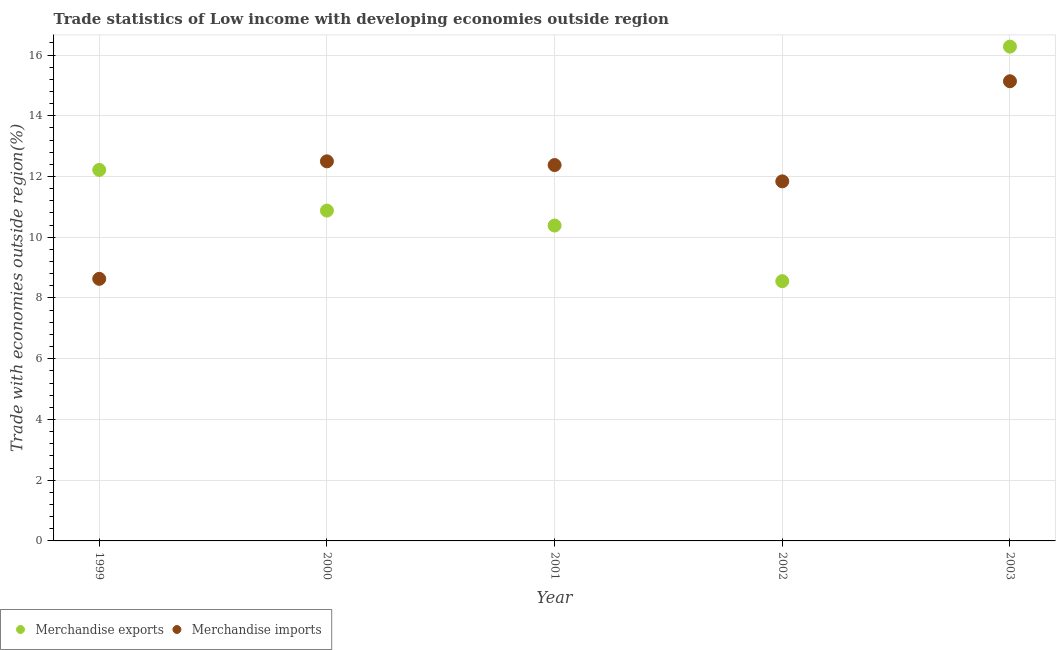How many different coloured dotlines are there?
Give a very brief answer. 2. What is the merchandise imports in 2002?
Give a very brief answer. 11.84. Across all years, what is the maximum merchandise imports?
Your response must be concise. 15.14. Across all years, what is the minimum merchandise imports?
Offer a terse response. 8.63. What is the total merchandise imports in the graph?
Offer a terse response. 60.48. What is the difference between the merchandise exports in 2001 and that in 2002?
Your response must be concise. 1.83. What is the difference between the merchandise exports in 1999 and the merchandise imports in 2000?
Provide a short and direct response. -0.28. What is the average merchandise imports per year?
Your response must be concise. 12.1. In the year 2003, what is the difference between the merchandise exports and merchandise imports?
Provide a succinct answer. 1.14. What is the ratio of the merchandise imports in 1999 to that in 2000?
Your response must be concise. 0.69. Is the difference between the merchandise imports in 2000 and 2001 greater than the difference between the merchandise exports in 2000 and 2001?
Keep it short and to the point. No. What is the difference between the highest and the second highest merchandise imports?
Offer a terse response. 2.64. What is the difference between the highest and the lowest merchandise exports?
Make the answer very short. 7.72. In how many years, is the merchandise exports greater than the average merchandise exports taken over all years?
Offer a terse response. 2. Is the sum of the merchandise imports in 2002 and 2003 greater than the maximum merchandise exports across all years?
Keep it short and to the point. Yes. Does the merchandise imports monotonically increase over the years?
Give a very brief answer. No. How many dotlines are there?
Ensure brevity in your answer.  2. How many years are there in the graph?
Provide a short and direct response. 5. Does the graph contain any zero values?
Your response must be concise. No. Does the graph contain grids?
Provide a succinct answer. Yes. Where does the legend appear in the graph?
Your response must be concise. Bottom left. How are the legend labels stacked?
Give a very brief answer. Horizontal. What is the title of the graph?
Offer a very short reply. Trade statistics of Low income with developing economies outside region. What is the label or title of the Y-axis?
Make the answer very short. Trade with economies outside region(%). What is the Trade with economies outside region(%) of Merchandise exports in 1999?
Offer a very short reply. 12.22. What is the Trade with economies outside region(%) in Merchandise imports in 1999?
Your response must be concise. 8.63. What is the Trade with economies outside region(%) in Merchandise exports in 2000?
Your response must be concise. 10.88. What is the Trade with economies outside region(%) of Merchandise imports in 2000?
Provide a succinct answer. 12.5. What is the Trade with economies outside region(%) of Merchandise exports in 2001?
Keep it short and to the point. 10.39. What is the Trade with economies outside region(%) in Merchandise imports in 2001?
Keep it short and to the point. 12.38. What is the Trade with economies outside region(%) in Merchandise exports in 2002?
Your answer should be compact. 8.55. What is the Trade with economies outside region(%) in Merchandise imports in 2002?
Make the answer very short. 11.84. What is the Trade with economies outside region(%) in Merchandise exports in 2003?
Provide a short and direct response. 16.28. What is the Trade with economies outside region(%) of Merchandise imports in 2003?
Make the answer very short. 15.14. Across all years, what is the maximum Trade with economies outside region(%) in Merchandise exports?
Your answer should be very brief. 16.28. Across all years, what is the maximum Trade with economies outside region(%) of Merchandise imports?
Your answer should be very brief. 15.14. Across all years, what is the minimum Trade with economies outside region(%) in Merchandise exports?
Provide a succinct answer. 8.55. Across all years, what is the minimum Trade with economies outside region(%) of Merchandise imports?
Provide a short and direct response. 8.63. What is the total Trade with economies outside region(%) in Merchandise exports in the graph?
Ensure brevity in your answer.  58.31. What is the total Trade with economies outside region(%) of Merchandise imports in the graph?
Provide a succinct answer. 60.48. What is the difference between the Trade with economies outside region(%) of Merchandise exports in 1999 and that in 2000?
Give a very brief answer. 1.34. What is the difference between the Trade with economies outside region(%) in Merchandise imports in 1999 and that in 2000?
Give a very brief answer. -3.87. What is the difference between the Trade with economies outside region(%) in Merchandise exports in 1999 and that in 2001?
Keep it short and to the point. 1.83. What is the difference between the Trade with economies outside region(%) of Merchandise imports in 1999 and that in 2001?
Offer a very short reply. -3.75. What is the difference between the Trade with economies outside region(%) in Merchandise exports in 1999 and that in 2002?
Offer a terse response. 3.66. What is the difference between the Trade with economies outside region(%) of Merchandise imports in 1999 and that in 2002?
Provide a succinct answer. -3.21. What is the difference between the Trade with economies outside region(%) in Merchandise exports in 1999 and that in 2003?
Give a very brief answer. -4.06. What is the difference between the Trade with economies outside region(%) in Merchandise imports in 1999 and that in 2003?
Provide a short and direct response. -6.51. What is the difference between the Trade with economies outside region(%) of Merchandise exports in 2000 and that in 2001?
Your answer should be compact. 0.49. What is the difference between the Trade with economies outside region(%) in Merchandise imports in 2000 and that in 2001?
Your response must be concise. 0.12. What is the difference between the Trade with economies outside region(%) in Merchandise exports in 2000 and that in 2002?
Offer a terse response. 2.32. What is the difference between the Trade with economies outside region(%) in Merchandise imports in 2000 and that in 2002?
Make the answer very short. 0.66. What is the difference between the Trade with economies outside region(%) in Merchandise exports in 2000 and that in 2003?
Offer a very short reply. -5.4. What is the difference between the Trade with economies outside region(%) in Merchandise imports in 2000 and that in 2003?
Provide a succinct answer. -2.64. What is the difference between the Trade with economies outside region(%) in Merchandise exports in 2001 and that in 2002?
Offer a terse response. 1.83. What is the difference between the Trade with economies outside region(%) of Merchandise imports in 2001 and that in 2002?
Give a very brief answer. 0.54. What is the difference between the Trade with economies outside region(%) in Merchandise exports in 2001 and that in 2003?
Make the answer very short. -5.89. What is the difference between the Trade with economies outside region(%) of Merchandise imports in 2001 and that in 2003?
Your answer should be compact. -2.76. What is the difference between the Trade with economies outside region(%) in Merchandise exports in 2002 and that in 2003?
Your answer should be compact. -7.72. What is the difference between the Trade with economies outside region(%) of Merchandise imports in 2002 and that in 2003?
Your answer should be compact. -3.3. What is the difference between the Trade with economies outside region(%) of Merchandise exports in 1999 and the Trade with economies outside region(%) of Merchandise imports in 2000?
Offer a terse response. -0.28. What is the difference between the Trade with economies outside region(%) of Merchandise exports in 1999 and the Trade with economies outside region(%) of Merchandise imports in 2001?
Provide a succinct answer. -0.16. What is the difference between the Trade with economies outside region(%) in Merchandise exports in 1999 and the Trade with economies outside region(%) in Merchandise imports in 2002?
Provide a short and direct response. 0.38. What is the difference between the Trade with economies outside region(%) of Merchandise exports in 1999 and the Trade with economies outside region(%) of Merchandise imports in 2003?
Your answer should be very brief. -2.92. What is the difference between the Trade with economies outside region(%) in Merchandise exports in 2000 and the Trade with economies outside region(%) in Merchandise imports in 2001?
Give a very brief answer. -1.5. What is the difference between the Trade with economies outside region(%) in Merchandise exports in 2000 and the Trade with economies outside region(%) in Merchandise imports in 2002?
Provide a short and direct response. -0.96. What is the difference between the Trade with economies outside region(%) in Merchandise exports in 2000 and the Trade with economies outside region(%) in Merchandise imports in 2003?
Give a very brief answer. -4.26. What is the difference between the Trade with economies outside region(%) in Merchandise exports in 2001 and the Trade with economies outside region(%) in Merchandise imports in 2002?
Offer a very short reply. -1.45. What is the difference between the Trade with economies outside region(%) of Merchandise exports in 2001 and the Trade with economies outside region(%) of Merchandise imports in 2003?
Give a very brief answer. -4.75. What is the difference between the Trade with economies outside region(%) in Merchandise exports in 2002 and the Trade with economies outside region(%) in Merchandise imports in 2003?
Give a very brief answer. -6.58. What is the average Trade with economies outside region(%) in Merchandise exports per year?
Make the answer very short. 11.66. What is the average Trade with economies outside region(%) in Merchandise imports per year?
Your answer should be very brief. 12.1. In the year 1999, what is the difference between the Trade with economies outside region(%) in Merchandise exports and Trade with economies outside region(%) in Merchandise imports?
Make the answer very short. 3.59. In the year 2000, what is the difference between the Trade with economies outside region(%) in Merchandise exports and Trade with economies outside region(%) in Merchandise imports?
Keep it short and to the point. -1.62. In the year 2001, what is the difference between the Trade with economies outside region(%) of Merchandise exports and Trade with economies outside region(%) of Merchandise imports?
Give a very brief answer. -1.99. In the year 2002, what is the difference between the Trade with economies outside region(%) in Merchandise exports and Trade with economies outside region(%) in Merchandise imports?
Offer a very short reply. -3.29. In the year 2003, what is the difference between the Trade with economies outside region(%) in Merchandise exports and Trade with economies outside region(%) in Merchandise imports?
Keep it short and to the point. 1.14. What is the ratio of the Trade with economies outside region(%) of Merchandise exports in 1999 to that in 2000?
Offer a very short reply. 1.12. What is the ratio of the Trade with economies outside region(%) of Merchandise imports in 1999 to that in 2000?
Ensure brevity in your answer.  0.69. What is the ratio of the Trade with economies outside region(%) in Merchandise exports in 1999 to that in 2001?
Keep it short and to the point. 1.18. What is the ratio of the Trade with economies outside region(%) of Merchandise imports in 1999 to that in 2001?
Your response must be concise. 0.7. What is the ratio of the Trade with economies outside region(%) in Merchandise exports in 1999 to that in 2002?
Make the answer very short. 1.43. What is the ratio of the Trade with economies outside region(%) in Merchandise imports in 1999 to that in 2002?
Ensure brevity in your answer.  0.73. What is the ratio of the Trade with economies outside region(%) of Merchandise exports in 1999 to that in 2003?
Provide a short and direct response. 0.75. What is the ratio of the Trade with economies outside region(%) of Merchandise imports in 1999 to that in 2003?
Keep it short and to the point. 0.57. What is the ratio of the Trade with economies outside region(%) in Merchandise exports in 2000 to that in 2001?
Offer a terse response. 1.05. What is the ratio of the Trade with economies outside region(%) of Merchandise imports in 2000 to that in 2001?
Provide a short and direct response. 1.01. What is the ratio of the Trade with economies outside region(%) in Merchandise exports in 2000 to that in 2002?
Your answer should be compact. 1.27. What is the ratio of the Trade with economies outside region(%) in Merchandise imports in 2000 to that in 2002?
Ensure brevity in your answer.  1.06. What is the ratio of the Trade with economies outside region(%) of Merchandise exports in 2000 to that in 2003?
Offer a very short reply. 0.67. What is the ratio of the Trade with economies outside region(%) of Merchandise imports in 2000 to that in 2003?
Your answer should be compact. 0.83. What is the ratio of the Trade with economies outside region(%) of Merchandise exports in 2001 to that in 2002?
Make the answer very short. 1.21. What is the ratio of the Trade with economies outside region(%) of Merchandise imports in 2001 to that in 2002?
Your answer should be compact. 1.05. What is the ratio of the Trade with economies outside region(%) in Merchandise exports in 2001 to that in 2003?
Your answer should be compact. 0.64. What is the ratio of the Trade with economies outside region(%) in Merchandise imports in 2001 to that in 2003?
Ensure brevity in your answer.  0.82. What is the ratio of the Trade with economies outside region(%) of Merchandise exports in 2002 to that in 2003?
Give a very brief answer. 0.53. What is the ratio of the Trade with economies outside region(%) in Merchandise imports in 2002 to that in 2003?
Ensure brevity in your answer.  0.78. What is the difference between the highest and the second highest Trade with economies outside region(%) of Merchandise exports?
Make the answer very short. 4.06. What is the difference between the highest and the second highest Trade with economies outside region(%) in Merchandise imports?
Your answer should be very brief. 2.64. What is the difference between the highest and the lowest Trade with economies outside region(%) in Merchandise exports?
Your answer should be compact. 7.72. What is the difference between the highest and the lowest Trade with economies outside region(%) of Merchandise imports?
Offer a very short reply. 6.51. 